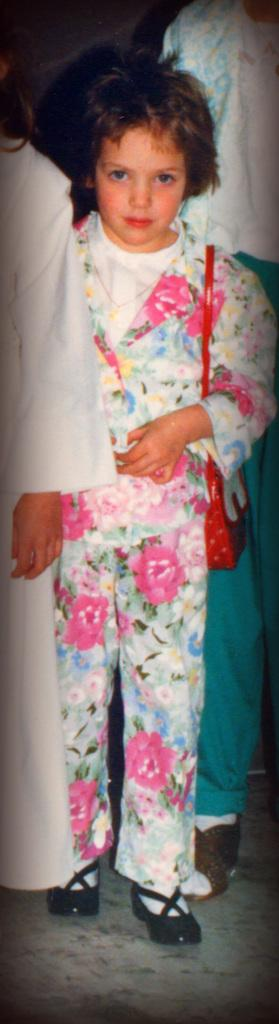What is the main subject of the image? The main subject of the image is a group of people. Can you describe the attire of the people in the image? The people in the image are wearing different color dresses. What is the color of the background in the image? The background of the image is black. Can you tell me how many girls are in the image? The provided facts do not mention the gender of the people in the image, so it is not possible to determine the number of girls. 